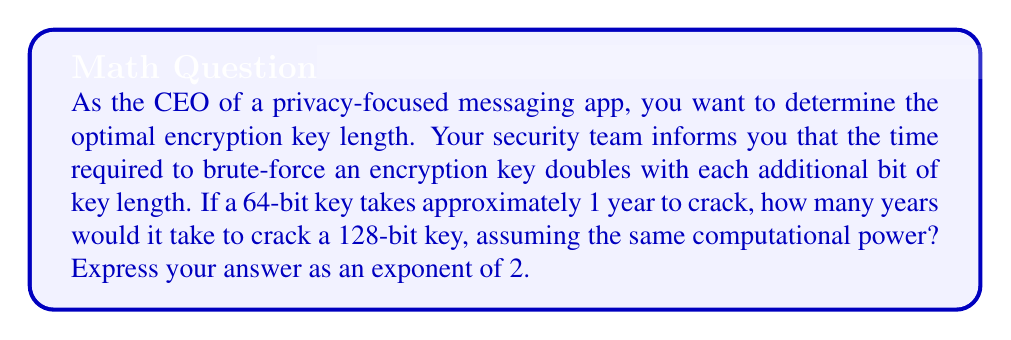Can you solve this math problem? Let's approach this step-by-step:

1) First, we need to understand the relationship between key length and cracking time:
   - Each additional bit doubles the time required
   - This can be expressed as a power of 2

2) We're increasing the key length from 64 bits to 128 bits:
   $128 - 64 = 64$ bits added

3) Each bit doubles the time, so we need to calculate $2^{64}$

4) The question asks how many years it would take. We know that:
   - 64-bit key takes 1 year
   - 128-bit key takes $2^{64}$ times longer

5) Therefore, the time to crack a 128-bit key is:
   $1 \text{ year} \times 2^{64} = 2^{64} \text{ years}$

This can be written as $2^{64}$ years, which is the form requested in the question.

To give a sense of scale: $2^{64}$ is approximately $1.8 \times 10^{19}$ years, which is vastly longer than the current age of the universe (about $1.4 \times 10^{10}$ years).
Answer: $2^{64}$ years 